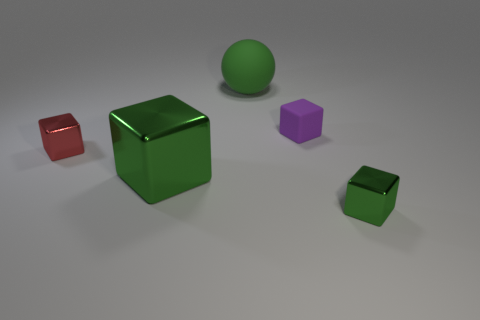There is a tiny purple matte thing; are there any big metallic blocks right of it?
Your response must be concise. No. There is a object that is made of the same material as the green sphere; what size is it?
Ensure brevity in your answer.  Small. What number of tiny green metallic objects are the same shape as the green matte thing?
Offer a very short reply. 0. Is the material of the small purple thing the same as the tiny red block left of the green sphere?
Provide a succinct answer. No. Is the number of red metallic blocks that are in front of the big green metal block greater than the number of small blue rubber cylinders?
Make the answer very short. No. There is a tiny thing that is the same color as the big matte sphere; what shape is it?
Your answer should be very brief. Cube. Are there any large green objects made of the same material as the big green sphere?
Your answer should be compact. No. Is the thing that is to the left of the big block made of the same material as the large green object that is right of the large green metallic cube?
Make the answer very short. No. Are there the same number of rubber cubes that are behind the purple block and big green shiny cubes in front of the small green object?
Offer a terse response. Yes. The shiny cube that is the same size as the red metal thing is what color?
Provide a succinct answer. Green. 